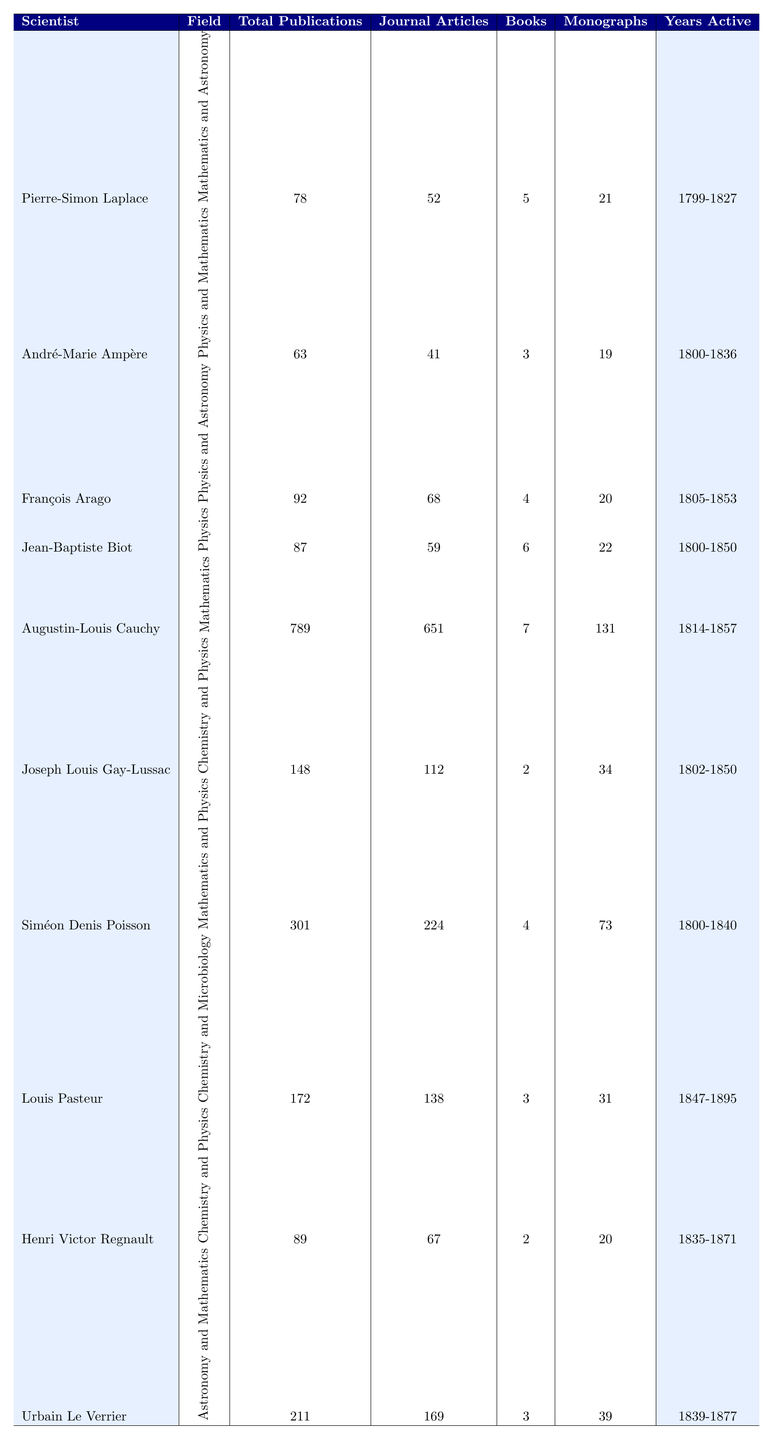What is the field of study for Louis Pasteur? Louis Pasteur's field of study is listed in the table under the "Field" column, which identifies him as a specialist in "Chemistry and Microbiology."
Answer: Chemistry and Microbiology Who published the most journal articles among the scientists listed? To find the scientist with the most journal articles, we compare the values in the "Journal Articles" column. Augustin-Louis Cauchy has 651 journal articles, which is the highest compared to the others.
Answer: Augustin-Louis Cauchy How many total publications did Siméon Denis Poisson have? Siméon Denis Poisson's total number of publications is found in the "Total Publications" column, where it shows he has 301 publications.
Answer: 301 What is the difference in total publications between François Arago and Joseph Louis Gay-Lussac? François Arago has 92 total publications, while Joseph Louis Gay-Lussac has 148 total publications. The difference is calculated as 148 - 92 = 56.
Answer: 56 Did André-Marie Ampère have more journal articles than Louis Pasteur? André-Marie Ampère has 41 journal articles, while Louis Pasteur has 138 journal articles. Since 41 is less than 138, the answer is no.
Answer: No What was the most cited work of Pierre-Simon Laplace? The most cited work of Pierre-Simon Laplace is specified in the "Most Cited Work" column, which states it is "Traité de Mécanique Céleste."
Answer: Traité de Mécanique Céleste Which scientist had the fewest number of books published? We can see from the "Books" column that André-Marie Ampère has published only 3 books, which is the lowest number among all listed scientists.
Answer: André-Marie Ampère Calculate the average number of monographs published by the scientists listed. Adding the values in the "Monographs" column gives 21 + 19 + 20 + 22 + 131 + 34 + 73 + 31 + 20 + 39 =  409. There are 10 scientists, so we divide by 10: 409/10 = 40.9.
Answer: 40.9 Which field has the highest total number of publications among the scientists? By reviewing the "Total Publications" column, we see that Augustin-Louis Cauchy has the most with 789 publications in Mathematics, making this field the highest overall.
Answer: Mathematics Is it true that Urbain Le Verrier had more total publications than Pierre-Simon Laplace? Urbain Le Verrier has 211 total publications, while Pierre-Simon Laplace has 78. Since 211 is greater than 78, the statement is true.
Answer: Yes 